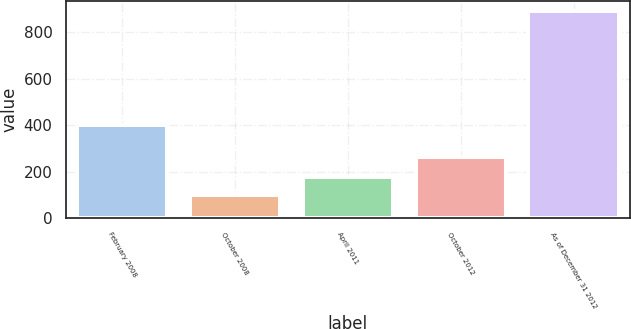Convert chart. <chart><loc_0><loc_0><loc_500><loc_500><bar_chart><fcel>February 2008<fcel>October 2008<fcel>April 2011<fcel>October 2012<fcel>As of December 31 2012<nl><fcel>400<fcel>100<fcel>179.3<fcel>264<fcel>893<nl></chart> 